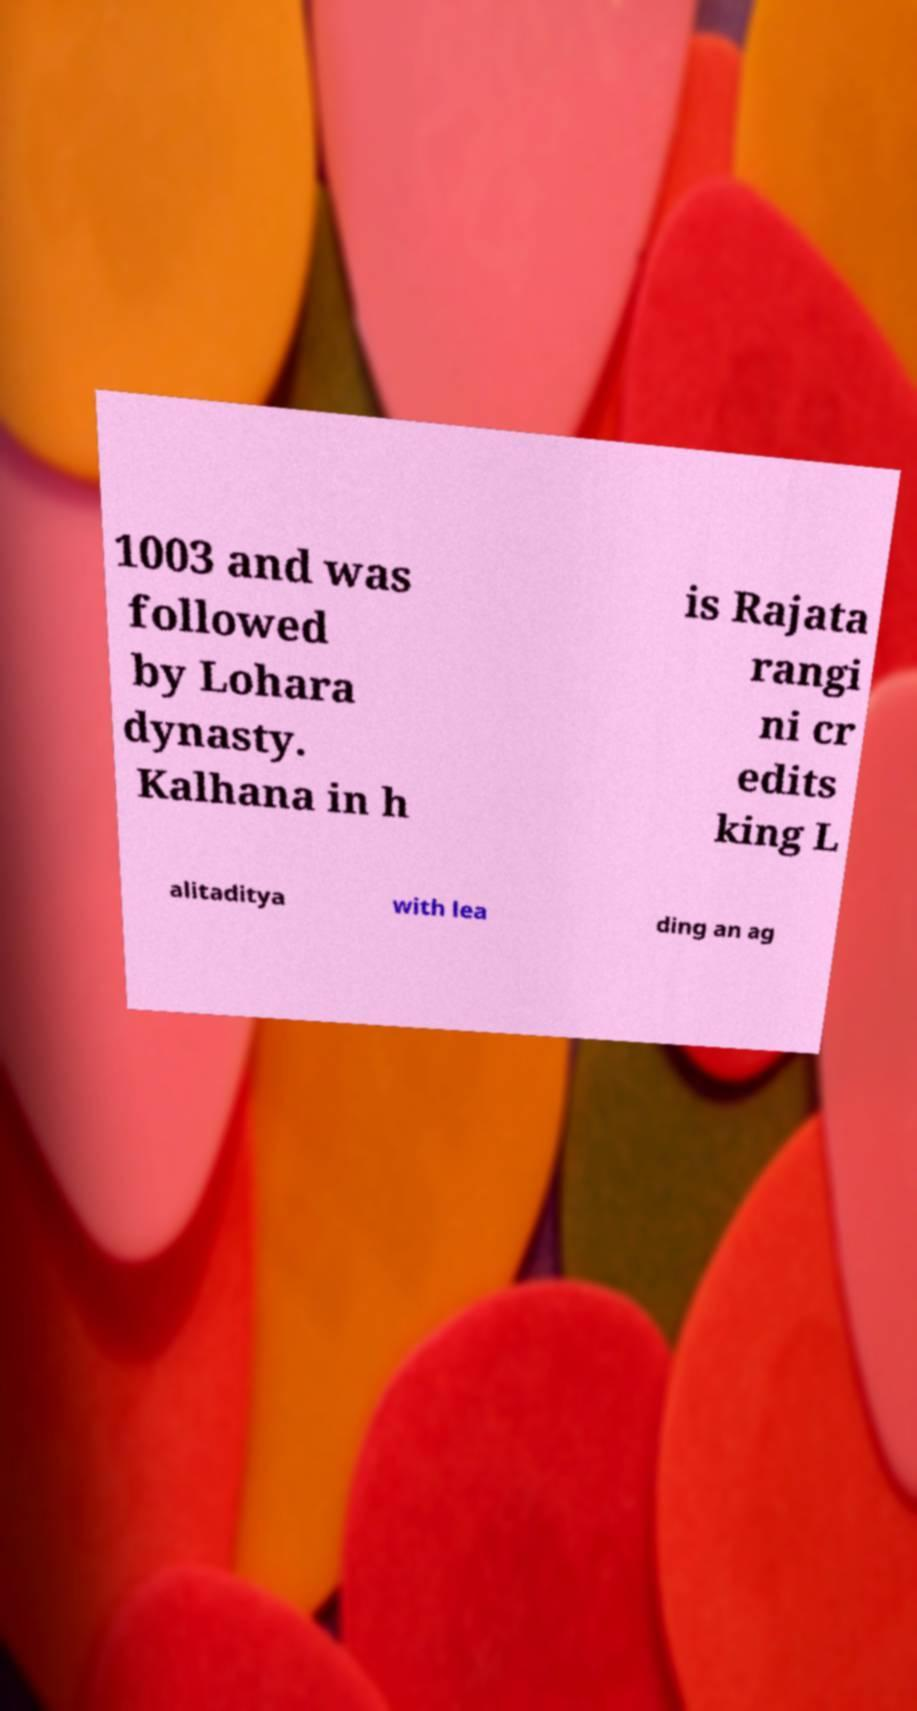Please read and relay the text visible in this image. What does it say? 1003 and was followed by Lohara dynasty. Kalhana in h is Rajata rangi ni cr edits king L alitaditya with lea ding an ag 